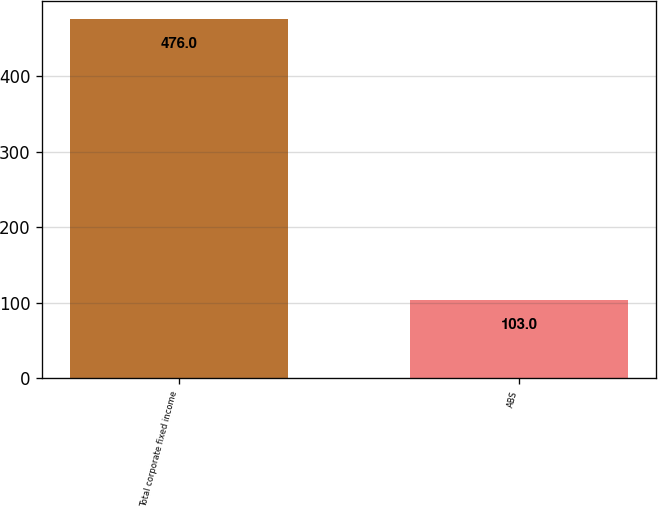Convert chart. <chart><loc_0><loc_0><loc_500><loc_500><bar_chart><fcel>Total corporate fixed income<fcel>ABS<nl><fcel>476<fcel>103<nl></chart> 